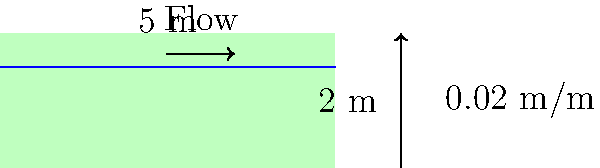Calculate the water flow rate in a rainforest stream with a rectangular cross-section. The stream is 5 m wide and 1.5 m deep, with a channel slope of 0.02 m/m. Assume a Manning's roughness coefficient of 0.03 for a natural stream. What is the flow rate in cubic meters per second (m³/s)? To calculate the flow rate, we'll use Manning's equation:

$$ Q = \frac{1}{n} A R^{2/3} S^{1/2} $$

Where:
$Q$ = flow rate (m³/s)
$n$ = Manning's roughness coefficient (0.03)
$A$ = cross-sectional area (m²)
$R$ = hydraulic radius (m)
$S$ = channel slope (m/m)

Step 1: Calculate the cross-sectional area (A)
$$ A = \text{width} \times \text{depth} = 5 \text{ m} \times 1.5 \text{ m} = 7.5 \text{ m}^2 $$

Step 2: Calculate the wetted perimeter (P)
$$ P = \text{width} + 2 \times \text{depth} = 5 \text{ m} + 2 \times 1.5 \text{ m} = 8 \text{ m} $$

Step 3: Calculate the hydraulic radius (R)
$$ R = \frac{A}{P} = \frac{7.5 \text{ m}^2}{8 \text{ m}} = 0.9375 \text{ m} $$

Step 4: Apply Manning's equation
$$ Q = \frac{1}{0.03} \times 7.5 \times 0.9375^{2/3} \times 0.02^{1/2} $$

Step 5: Solve for Q
$$ Q \approx 30.84 \text{ m}^3/\text{s} $$
Answer: 30.84 m³/s 